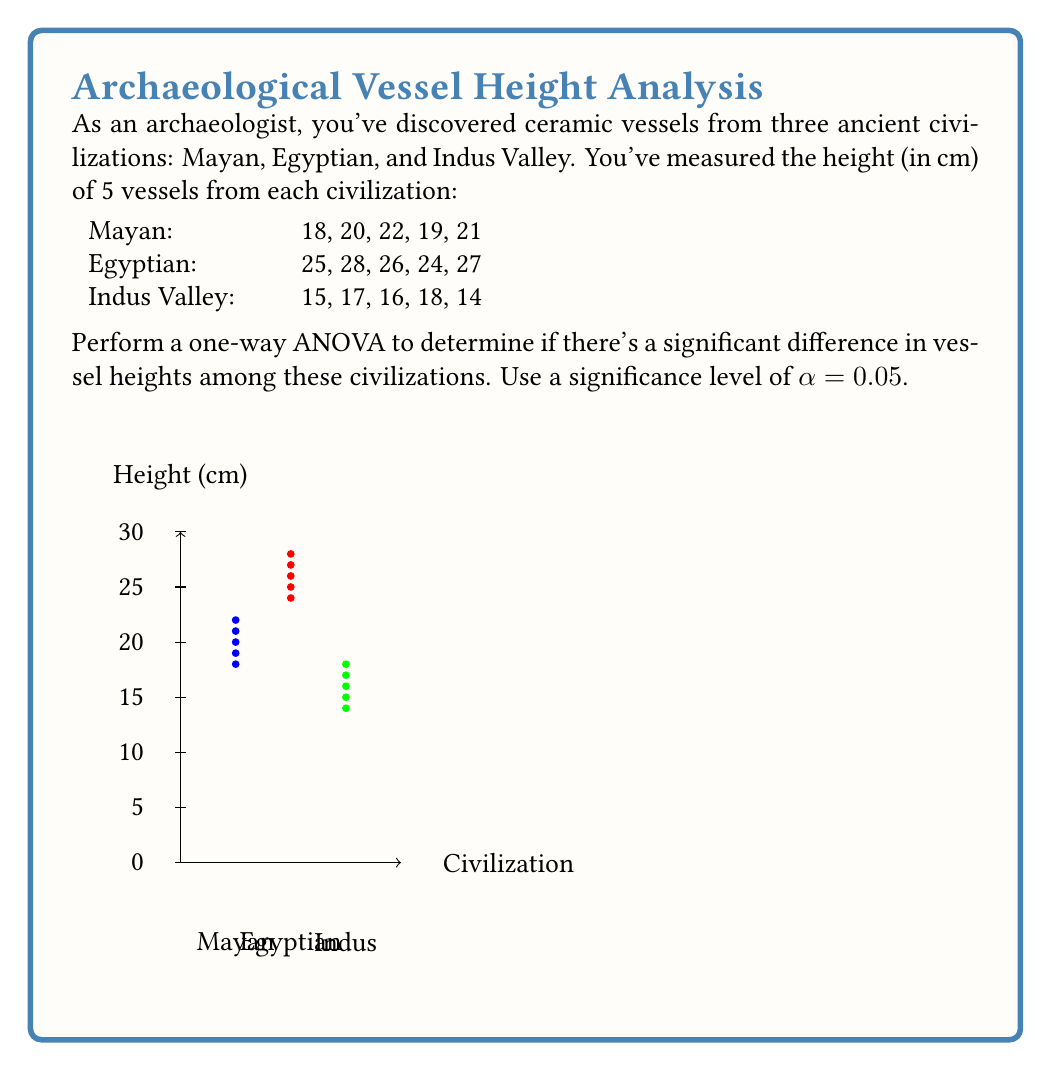Provide a solution to this math problem. Let's perform the one-way ANOVA step by step:

1) Calculate the mean for each group:
   Mayan: $\bar{x}_M = \frac{18+20+22+19+21}{5} = 20$
   Egyptian: $\bar{x}_E = \frac{25+28+26+24+27}{5} = 26$
   Indus Valley: $\bar{x}_I = \frac{15+17+16+18+14}{5} = 16$

2) Calculate the grand mean:
   $\bar{x} = \frac{20+26+16}{3} = 20.67$

3) Calculate the Sum of Squares Between (SSB):
   $SSB = 5[(20-20.67)^2 + (26-20.67)^2 + (16-20.67)^2] = 250$

4) Calculate the Sum of Squares Within (SSW):
   $SSW_M = (18-20)^2 + (20-20)^2 + (22-20)^2 + (19-20)^2 + (21-20)^2 = 10$
   $SSW_E = (25-26)^2 + (28-26)^2 + (26-26)^2 + (24-26)^2 + (27-26)^2 = 10$
   $SSW_I = (15-16)^2 + (17-16)^2 + (16-16)^2 + (18-16)^2 + (14-16)^2 = 10$
   $SSW = 10 + 10 + 10 = 30$

5) Calculate degrees of freedom:
   $df_{between} = 3 - 1 = 2$
   $df_{within} = 15 - 3 = 12$

6) Calculate Mean Square Between (MSB) and Mean Square Within (MSW):
   $MSB = \frac{SSB}{df_{between}} = \frac{250}{2} = 125$
   $MSW = \frac{SSW}{df_{within}} = \frac{30}{12} = 2.5$

7) Calculate F-statistic:
   $F = \frac{MSB}{MSW} = \frac{125}{2.5} = 50$

8) Find the critical F-value:
   For $α = 0.05$, $df_{between} = 2$, and $df_{within} = 12$, 
   $F_{critical} = 3.89$ (from F-distribution table)

9) Compare F-statistic to F-critical:
   Since $50 > 3.89$, we reject the null hypothesis.

Therefore, there is a significant difference in vessel heights among these civilizations at the 0.05 significance level.
Answer: $F(2,12) = 50, p < 0.05$. Significant difference exists. 